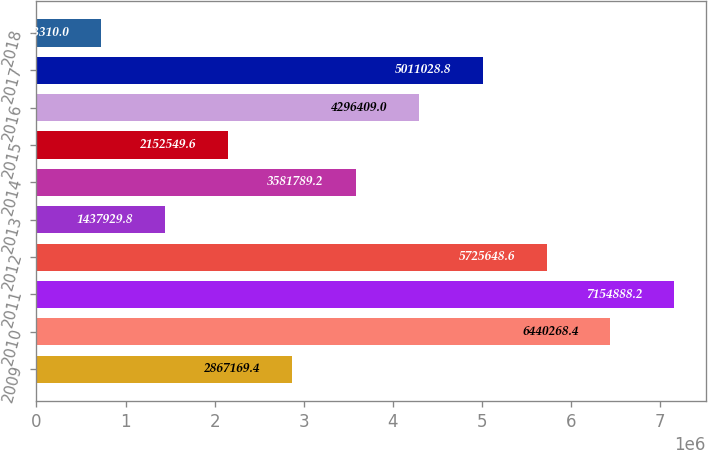Convert chart to OTSL. <chart><loc_0><loc_0><loc_500><loc_500><bar_chart><fcel>2009<fcel>2010<fcel>2011<fcel>2012<fcel>2013<fcel>2014<fcel>2015<fcel>2016<fcel>2017<fcel>2018<nl><fcel>2.86717e+06<fcel>6.44027e+06<fcel>7.15489e+06<fcel>5.72565e+06<fcel>1.43793e+06<fcel>3.58179e+06<fcel>2.15255e+06<fcel>4.29641e+06<fcel>5.01103e+06<fcel>723310<nl></chart> 